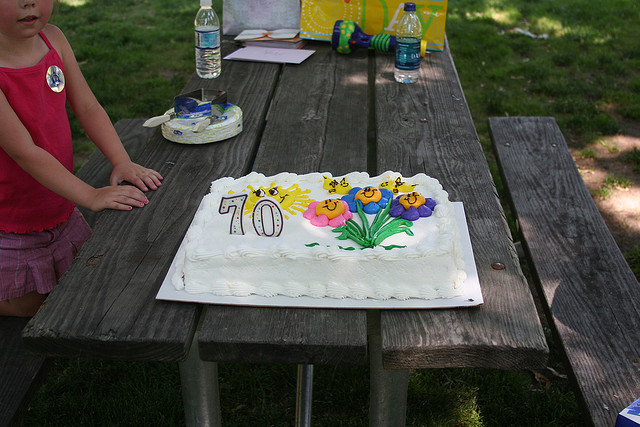Extract all visible text content from this image. 7 O 